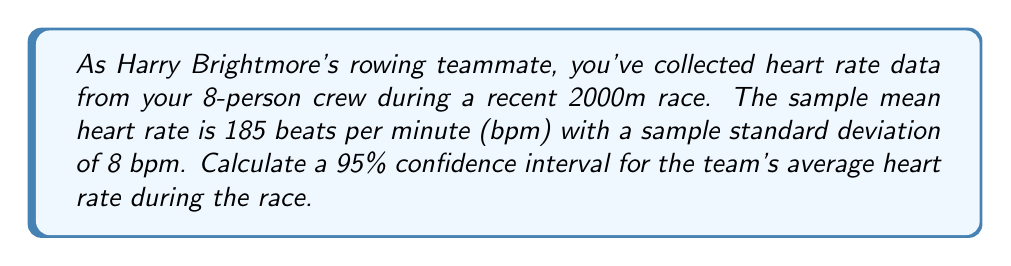Can you answer this question? To calculate the confidence interval, we'll use the formula:

$$ \text{CI} = \bar{x} \pm t_{\alpha/2, n-1} \cdot \frac{s}{\sqrt{n}} $$

Where:
$\bar{x}$ = sample mean = 185 bpm
$s$ = sample standard deviation = 8 bpm
$n$ = sample size = 8
$t_{\alpha/2, n-1}$ = t-value for 95% confidence level with 7 degrees of freedom

Steps:
1) Find the t-value:
   For 95% confidence and 7 degrees of freedom, $t_{0.025, 7} = 2.365$ (from t-distribution table)

2) Calculate the margin of error:
   $$ \text{Margin of Error} = t_{\alpha/2, n-1} \cdot \frac{s}{\sqrt{n}} = 2.365 \cdot \frac{8}{\sqrt{8}} = 6.68 $$

3) Calculate the confidence interval:
   $$ \text{CI} = 185 \pm 6.68 $$
   $$ \text{CI} = (178.32, 191.68) $$

4) Round to one decimal place:
   $$ \text{CI} = (178.3, 191.7) $$
Answer: (178.3, 191.7) bpm 